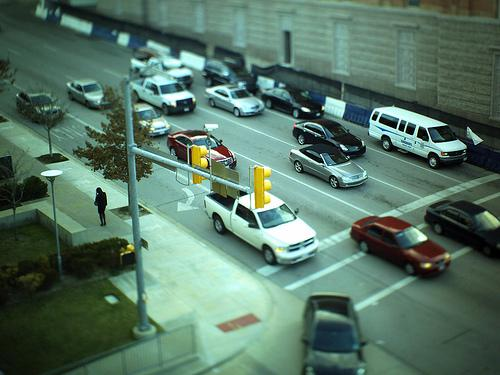Question: what is directing the traffic through the intersection?
Choices:
A. The stoplight.
B. Police officer.
C. Signs.
D. Cones.
Answer with the letter. Answer: A Question: what is painted on the street?
Choices:
A. Numbers.
B. Instructions.
C. Lines.
D. Dashes.
Answer with the letter. Answer: C Question: what direction is the car at the bottom of the picture turning?
Choices:
A. Right.
B. North.
C. Left.
D. East.
Answer with the letter. Answer: A Question: when was the picture taken?
Choices:
A. During the day.
B. After wedding.
C. Dusk.
D. Sunrise.
Answer with the letter. Answer: A Question: who is on the sidewalk?
Choices:
A. Little girl.
B. The person.
C. Elderly couple.
D. Clown.
Answer with the letter. Answer: B Question: how many vehicles are in the picture?
Choices:
A. 16.
B. 2.
C. 3.
D. 4.
Answer with the letter. Answer: A Question: how many vehicles are in the lane turning right?
Choices:
A. 3.
B. 4.
C. 5.
D. 6.
Answer with the letter. Answer: A 